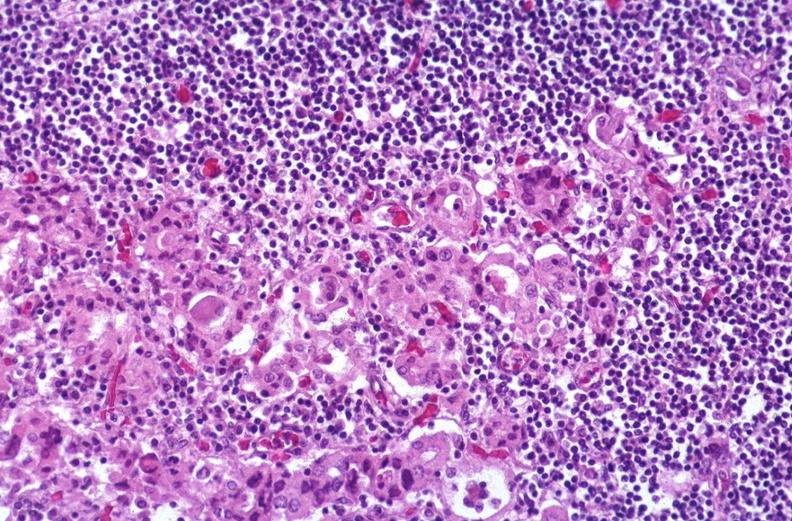does this image show hashimoto 's thyroiditis?
Answer the question using a single word or phrase. Yes 